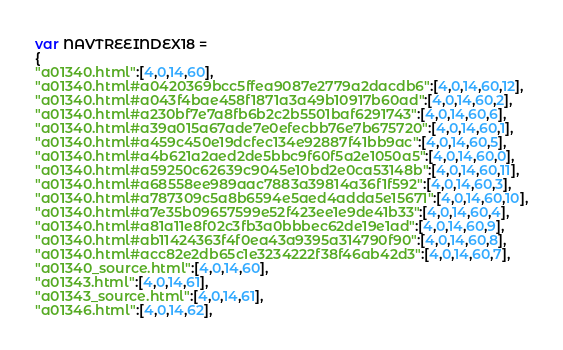Convert code to text. <code><loc_0><loc_0><loc_500><loc_500><_JavaScript_>var NAVTREEINDEX18 =
{
"a01340.html":[4,0,14,60],
"a01340.html#a0420369bcc5ffea9087e2779a2dacdb6":[4,0,14,60,12],
"a01340.html#a043f4bae458f1871a3a49b10917b60ad":[4,0,14,60,2],
"a01340.html#a230bf7e7a8fb6b2c2b5501baf6291743":[4,0,14,60,6],
"a01340.html#a39a015a67ade7e0efecbb76e7b675720":[4,0,14,60,1],
"a01340.html#a459c450e19dcfec134e92887f41bb9ac":[4,0,14,60,5],
"a01340.html#a4b621a2aed2de5bbc9f60f5a2e1050a5":[4,0,14,60,0],
"a01340.html#a59250c62639c9045e10bd2e0ca53148b":[4,0,14,60,11],
"a01340.html#a68558ee989aac7883a39814a36f1f592":[4,0,14,60,3],
"a01340.html#a787309c5a8b6594e5aed4adda5e15671":[4,0,14,60,10],
"a01340.html#a7e35b09657599e52f423ee1e9de41b33":[4,0,14,60,4],
"a01340.html#a81a11e8f02c3fb3a0bbbec62de19e1ad":[4,0,14,60,9],
"a01340.html#ab11424363f4f0ea43a9395a314790f90":[4,0,14,60,8],
"a01340.html#acc82e2db65c1e3234222f38f46ab42d3":[4,0,14,60,7],
"a01340_source.html":[4,0,14,60],
"a01343.html":[4,0,14,61],
"a01343_source.html":[4,0,14,61],
"a01346.html":[4,0,14,62],</code> 